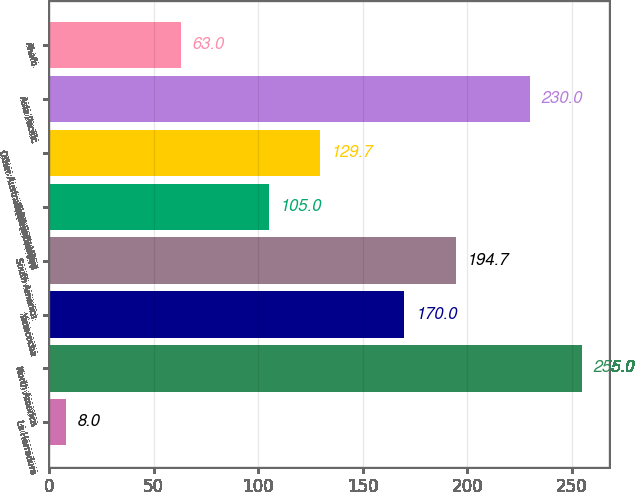Convert chart to OTSL. <chart><loc_0><loc_0><loc_500><loc_500><bar_chart><fcel>La Herradura<fcel>North America<fcel>Yanacocha<fcel>South America<fcel>Total Batu Hijau<fcel>Other Australia/New Zealand<fcel>Asia Pacific<fcel>Ahafo<nl><fcel>8<fcel>255<fcel>170<fcel>194.7<fcel>105<fcel>129.7<fcel>230<fcel>63<nl></chart> 